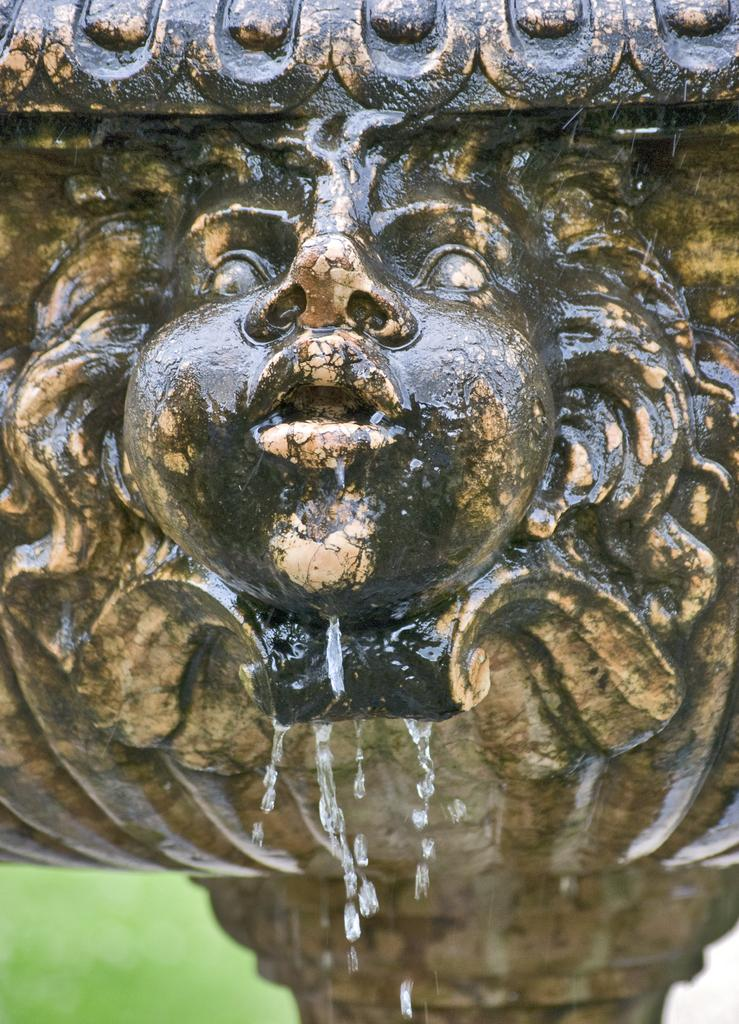What is the main subject of the image? There is a sculpture in the image. What is happening to the sculpture? Water is falling from the sculpture. What type of iron is being used to create the aftermath of the carriage accident in the image? There is no iron, aftermath, or carriage accident present in the image. The image only features a sculpture with water falling from it. 